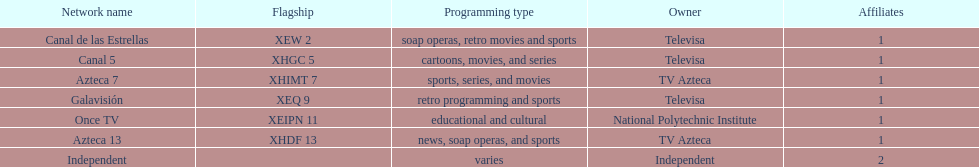How many affiliates does galavision have? 1. 